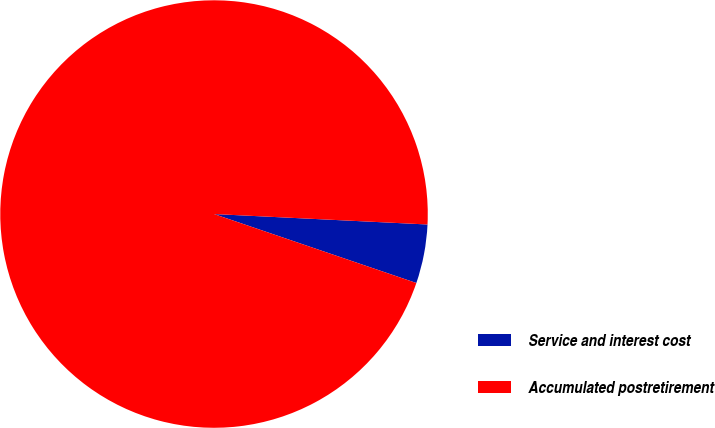<chart> <loc_0><loc_0><loc_500><loc_500><pie_chart><fcel>Service and interest cost<fcel>Accumulated postretirement<nl><fcel>4.45%<fcel>95.55%<nl></chart> 